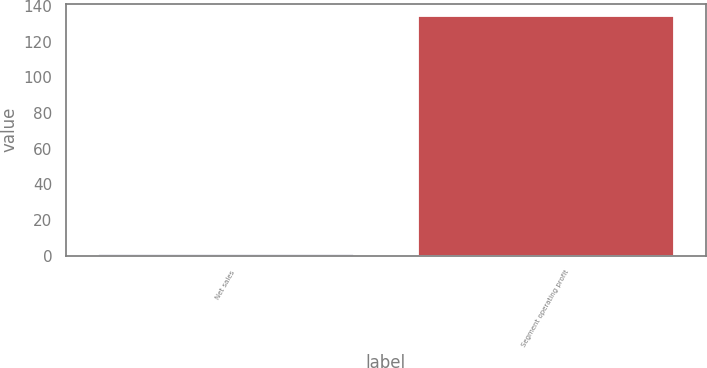Convert chart. <chart><loc_0><loc_0><loc_500><loc_500><bar_chart><fcel>Net sales<fcel>Segment operating profit<nl><fcel>0.8<fcel>134.5<nl></chart> 